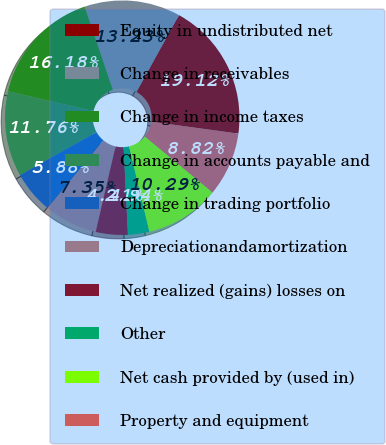<chart> <loc_0><loc_0><loc_500><loc_500><pie_chart><fcel>Equity in undistributed net<fcel>Change in receivables<fcel>Change in income taxes<fcel>Change in accounts payable and<fcel>Change in trading portfolio<fcel>Depreciationandamortization<fcel>Net realized (gains) losses on<fcel>Other<fcel>Net cash provided by (used in)<fcel>Property and equipment<nl><fcel>19.12%<fcel>13.23%<fcel>16.18%<fcel>11.76%<fcel>5.88%<fcel>7.35%<fcel>4.41%<fcel>2.94%<fcel>10.29%<fcel>8.82%<nl></chart> 